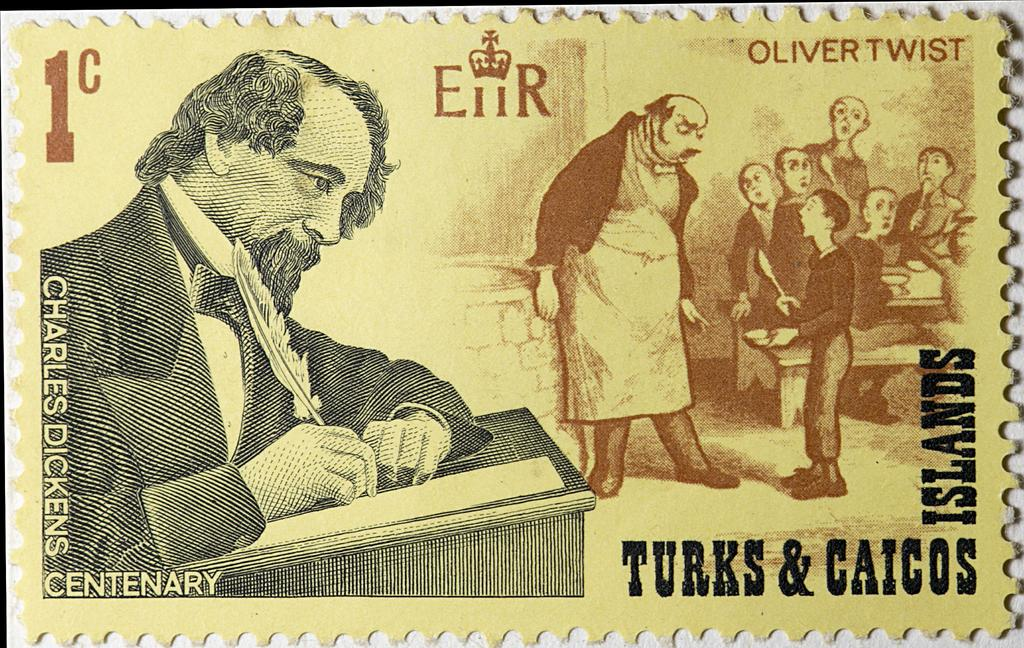What is the main subject of the image? The main subject of the image is postage stamps. Can you describe the appearance of the postage stamps? Unfortunately, the appearance of the postage stamps cannot be described without more specific information about their design or features. What type of plough is depicted on the postage stamps? There is no plough present on the postage stamps, as the image only shows postage stamps and no other objects or subjects. 